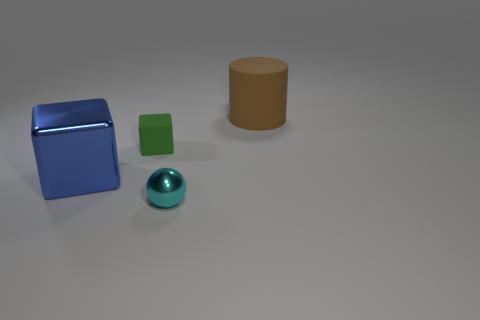Add 3 cyan balls. How many objects exist? 7 Subtract all balls. How many objects are left? 3 Subtract all tiny cyan things. Subtract all tiny matte blocks. How many objects are left? 2 Add 4 small green objects. How many small green objects are left? 5 Add 3 tiny red objects. How many tiny red objects exist? 3 Subtract 0 green cylinders. How many objects are left? 4 